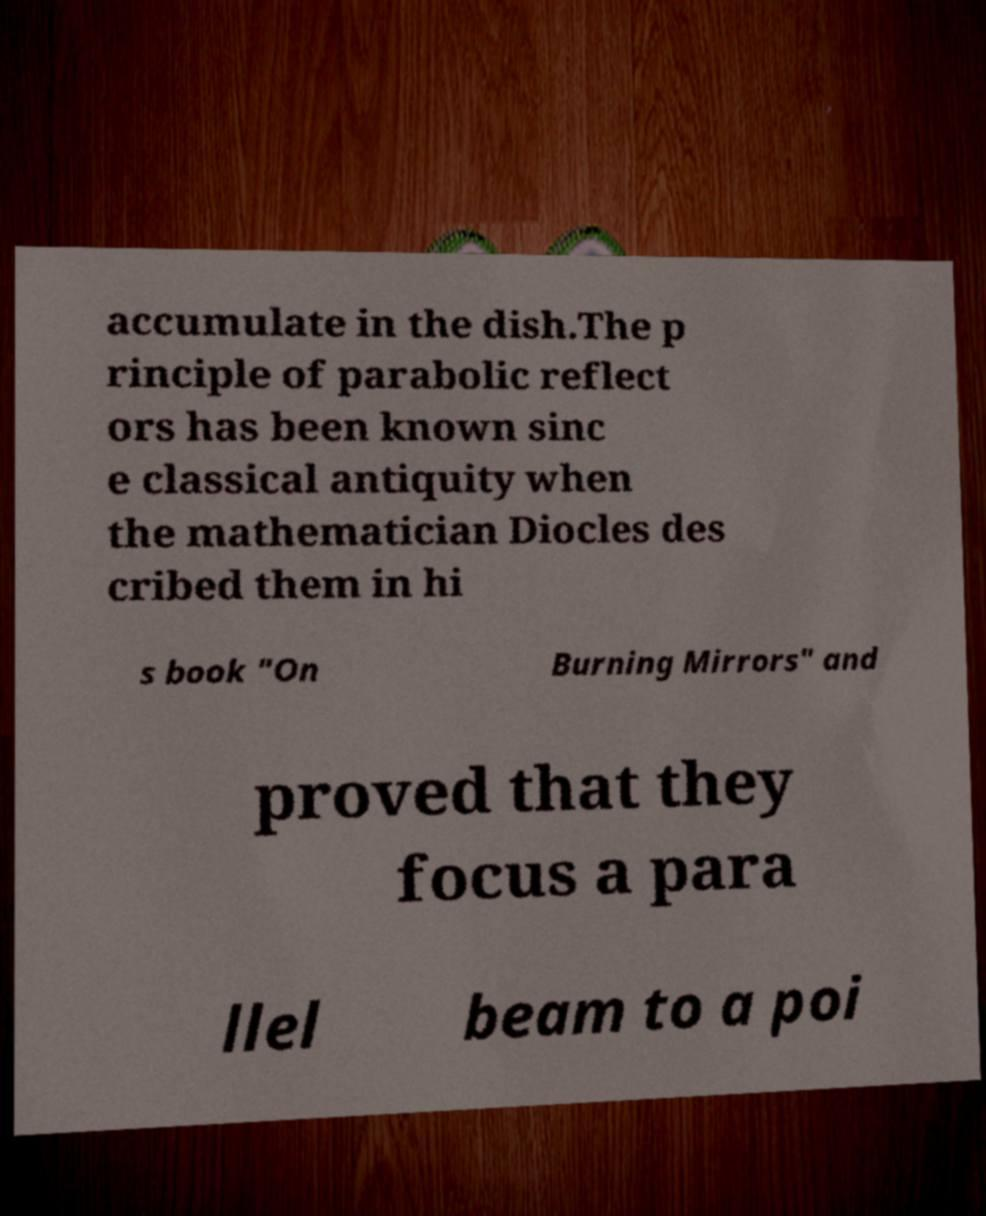Can you accurately transcribe the text from the provided image for me? accumulate in the dish.The p rinciple of parabolic reflect ors has been known sinc e classical antiquity when the mathematician Diocles des cribed them in hi s book "On Burning Mirrors" and proved that they focus a para llel beam to a poi 